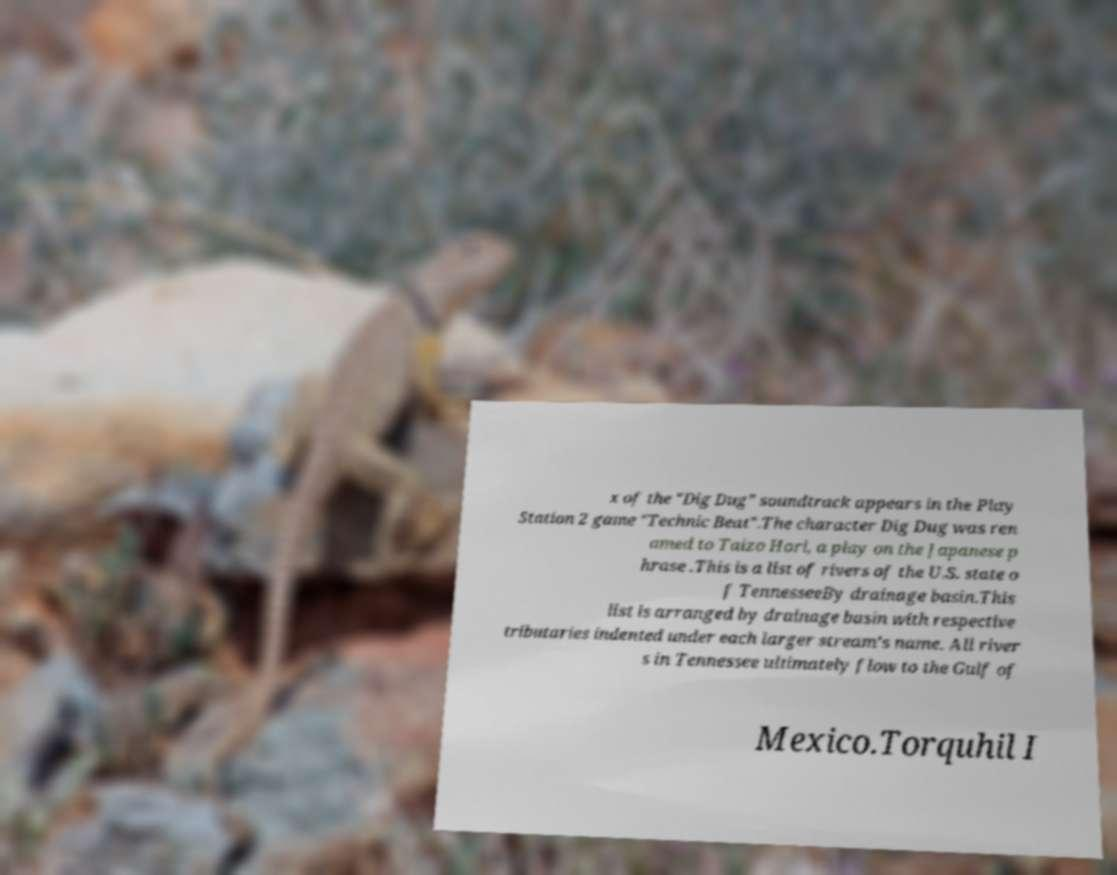There's text embedded in this image that I need extracted. Can you transcribe it verbatim? x of the "Dig Dug" soundtrack appears in the Play Station 2 game "Technic Beat".The character Dig Dug was ren amed to Taizo Hori, a play on the Japanese p hrase .This is a list of rivers of the U.S. state o f TennesseeBy drainage basin.This list is arranged by drainage basin with respective tributaries indented under each larger stream's name. All river s in Tennessee ultimately flow to the Gulf of Mexico.Torquhil I 